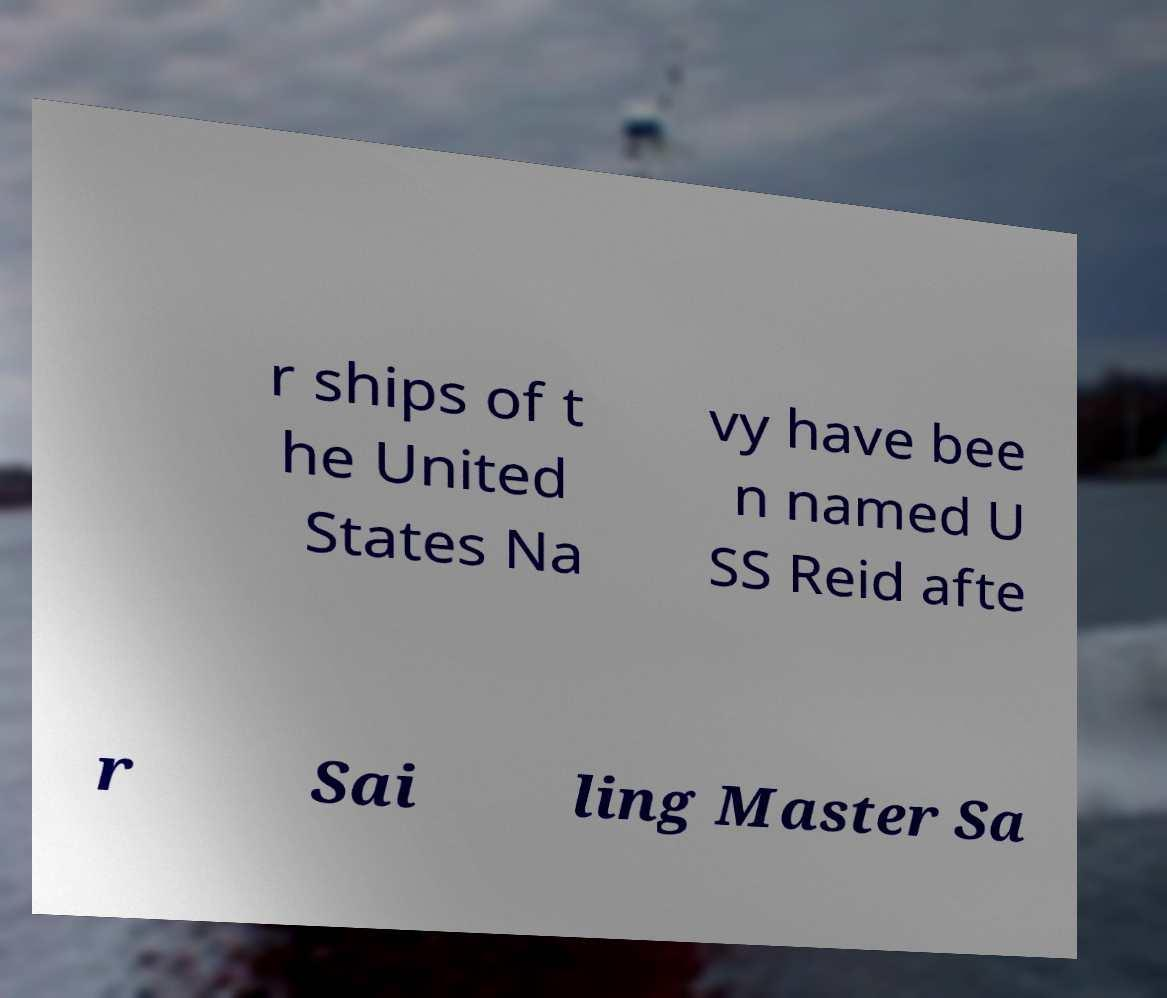Please identify and transcribe the text found in this image. r ships of t he United States Na vy have bee n named U SS Reid afte r Sai ling Master Sa 